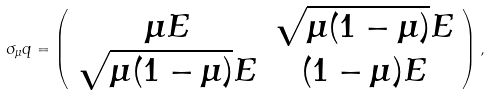Convert formula to latex. <formula><loc_0><loc_0><loc_500><loc_500>\sigma _ { \mu } q = \left ( \begin{array} { c c } \mu E & \sqrt { \mu ( 1 - \mu ) } E \\ \sqrt { \mu ( 1 - \mu ) } E & ( 1 - \mu ) E \end{array} \right ) ,</formula> 